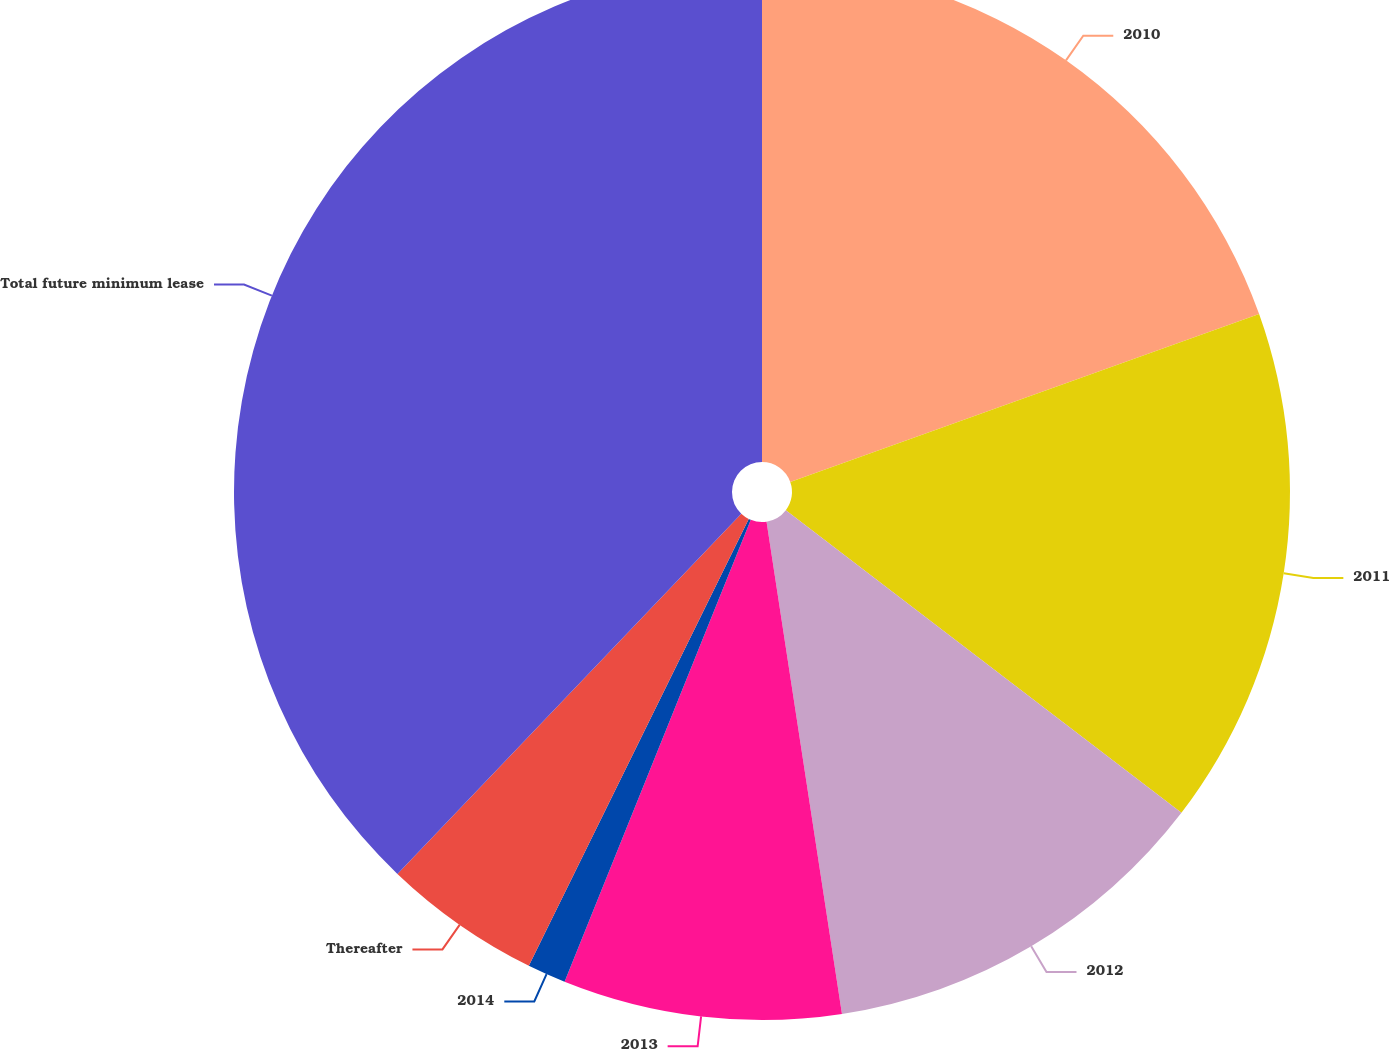Convert chart. <chart><loc_0><loc_0><loc_500><loc_500><pie_chart><fcel>2010<fcel>2011<fcel>2012<fcel>2013<fcel>2014<fcel>Thereafter<fcel>Total future minimum lease<nl><fcel>19.53%<fcel>15.86%<fcel>12.19%<fcel>8.52%<fcel>1.18%<fcel>4.85%<fcel>37.87%<nl></chart> 